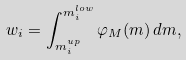Convert formula to latex. <formula><loc_0><loc_0><loc_500><loc_500>w _ { i } = \int _ { m _ { i } ^ { u p } } ^ { m _ { i } ^ { l o w } } \varphi _ { M } ( m ) \, d m ,</formula> 